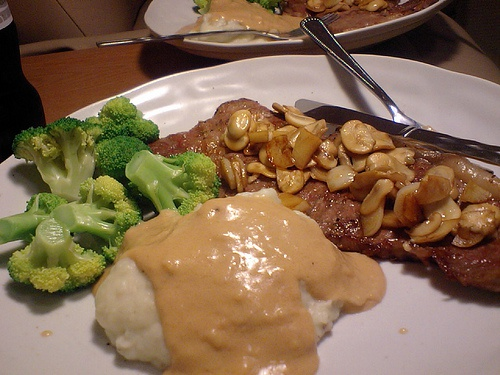Describe the objects in this image and their specific colors. I can see broccoli in black, olive, and darkgreen tones, dining table in black, maroon, and brown tones, bottle in black, gray, and maroon tones, knife in black, maroon, gray, and darkgray tones, and fork in black, gray, maroon, and darkgray tones in this image. 